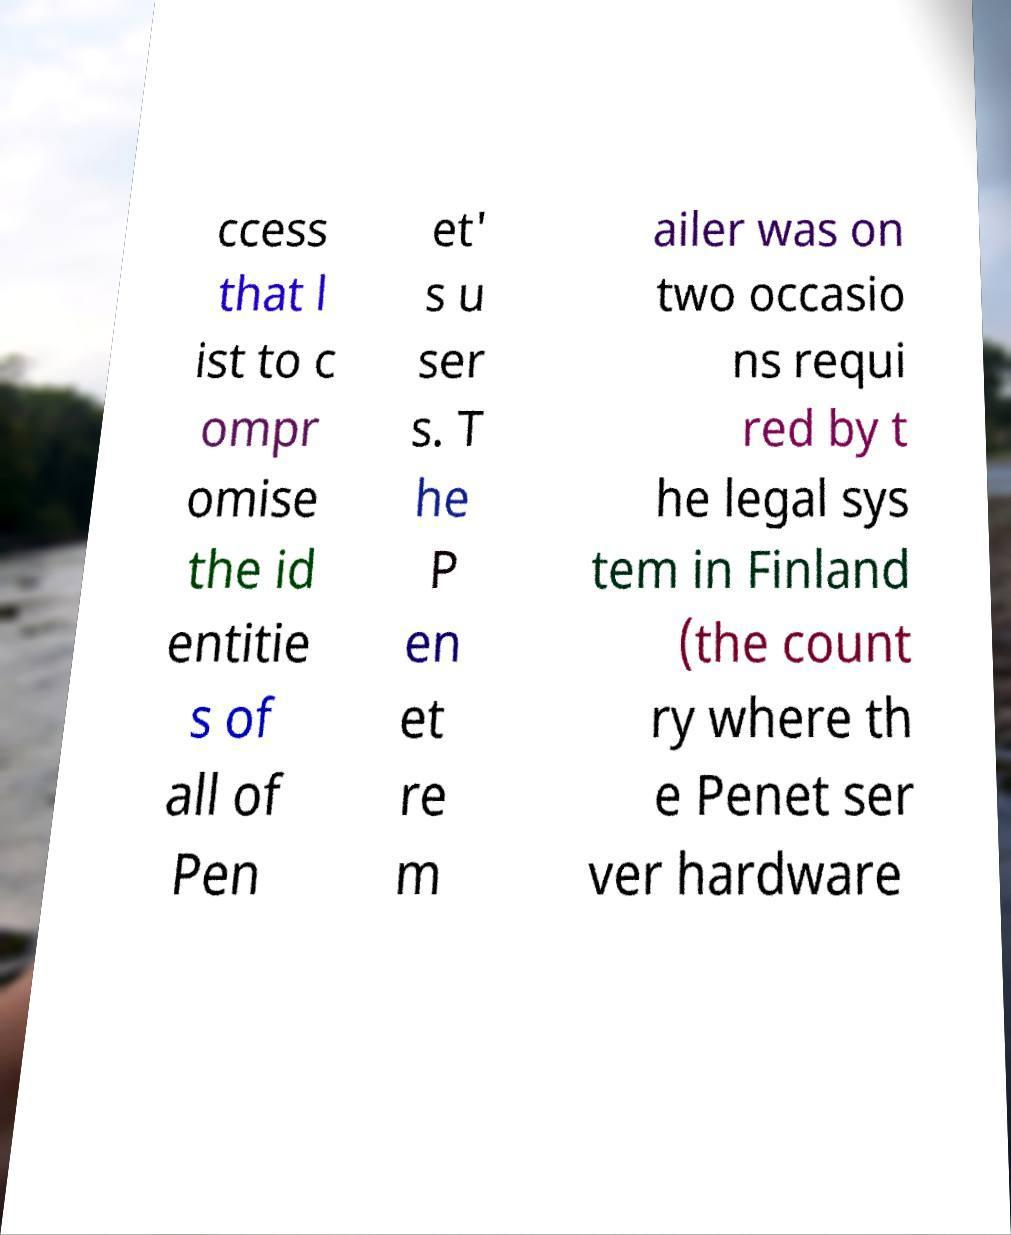Can you accurately transcribe the text from the provided image for me? ccess that l ist to c ompr omise the id entitie s of all of Pen et' s u ser s. T he P en et re m ailer was on two occasio ns requi red by t he legal sys tem in Finland (the count ry where th e Penet ser ver hardware 